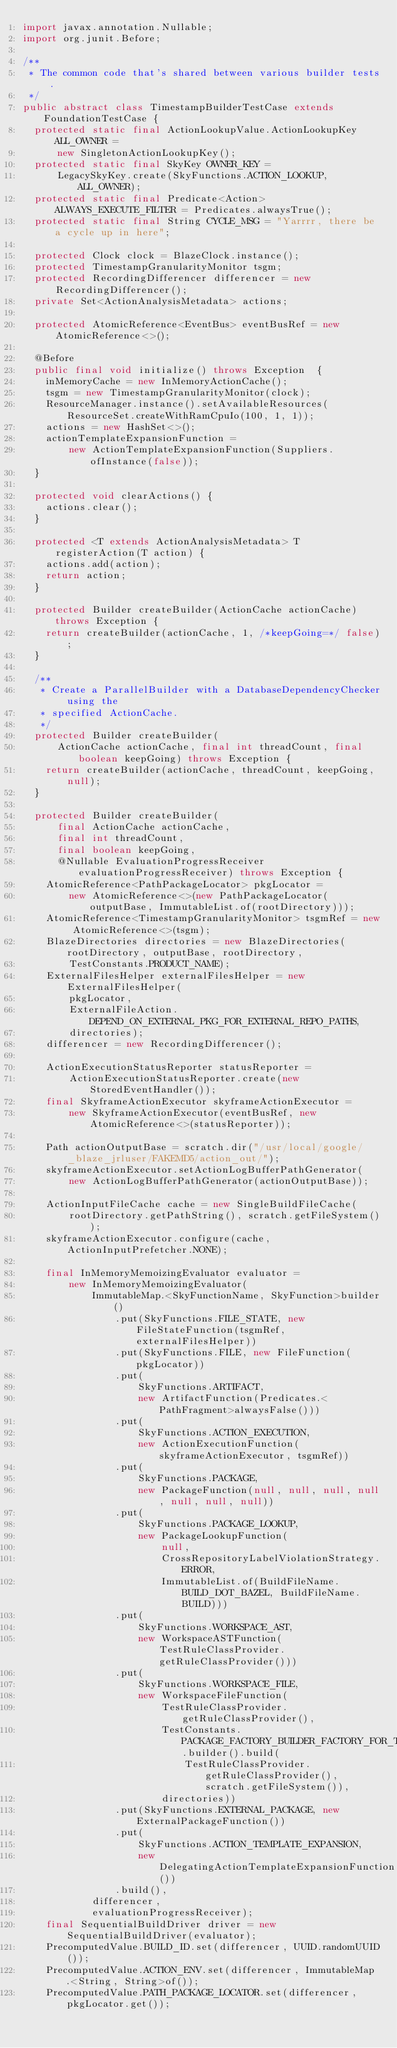<code> <loc_0><loc_0><loc_500><loc_500><_Java_>import javax.annotation.Nullable;
import org.junit.Before;

/**
 * The common code that's shared between various builder tests.
 */
public abstract class TimestampBuilderTestCase extends FoundationTestCase {
  protected static final ActionLookupValue.ActionLookupKey ALL_OWNER =
      new SingletonActionLookupKey();
  protected static final SkyKey OWNER_KEY =
      LegacySkyKey.create(SkyFunctions.ACTION_LOOKUP, ALL_OWNER);
  protected static final Predicate<Action> ALWAYS_EXECUTE_FILTER = Predicates.alwaysTrue();
  protected static final String CYCLE_MSG = "Yarrrr, there be a cycle up in here";

  protected Clock clock = BlazeClock.instance();
  protected TimestampGranularityMonitor tsgm;
  protected RecordingDifferencer differencer = new RecordingDifferencer();
  private Set<ActionAnalysisMetadata> actions;

  protected AtomicReference<EventBus> eventBusRef = new AtomicReference<>();

  @Before
  public final void initialize() throws Exception  {
    inMemoryCache = new InMemoryActionCache();
    tsgm = new TimestampGranularityMonitor(clock);
    ResourceManager.instance().setAvailableResources(ResourceSet.createWithRamCpuIo(100, 1, 1));
    actions = new HashSet<>();
    actionTemplateExpansionFunction =
        new ActionTemplateExpansionFunction(Suppliers.ofInstance(false));
  }

  protected void clearActions() {
    actions.clear();
  }

  protected <T extends ActionAnalysisMetadata> T registerAction(T action) {
    actions.add(action);
    return action;
  }

  protected Builder createBuilder(ActionCache actionCache) throws Exception {
    return createBuilder(actionCache, 1, /*keepGoing=*/ false);
  }

  /**
   * Create a ParallelBuilder with a DatabaseDependencyChecker using the
   * specified ActionCache.
   */
  protected Builder createBuilder(
      ActionCache actionCache, final int threadCount, final boolean keepGoing) throws Exception {
    return createBuilder(actionCache, threadCount, keepGoing, null);
  }

  protected Builder createBuilder(
      final ActionCache actionCache,
      final int threadCount,
      final boolean keepGoing,
      @Nullable EvaluationProgressReceiver evaluationProgressReceiver) throws Exception {
    AtomicReference<PathPackageLocator> pkgLocator =
        new AtomicReference<>(new PathPackageLocator(outputBase, ImmutableList.of(rootDirectory)));
    AtomicReference<TimestampGranularityMonitor> tsgmRef = new AtomicReference<>(tsgm);
    BlazeDirectories directories = new BlazeDirectories(rootDirectory, outputBase, rootDirectory,
        TestConstants.PRODUCT_NAME);
    ExternalFilesHelper externalFilesHelper = new ExternalFilesHelper(
        pkgLocator,
        ExternalFileAction.DEPEND_ON_EXTERNAL_PKG_FOR_EXTERNAL_REPO_PATHS,
        directories);
    differencer = new RecordingDifferencer();

    ActionExecutionStatusReporter statusReporter =
        ActionExecutionStatusReporter.create(new StoredEventHandler());
    final SkyframeActionExecutor skyframeActionExecutor =
        new SkyframeActionExecutor(eventBusRef, new AtomicReference<>(statusReporter));

    Path actionOutputBase = scratch.dir("/usr/local/google/_blaze_jrluser/FAKEMD5/action_out/");
    skyframeActionExecutor.setActionLogBufferPathGenerator(
        new ActionLogBufferPathGenerator(actionOutputBase));

    ActionInputFileCache cache = new SingleBuildFileCache(
        rootDirectory.getPathString(), scratch.getFileSystem());
    skyframeActionExecutor.configure(cache, ActionInputPrefetcher.NONE);

    final InMemoryMemoizingEvaluator evaluator =
        new InMemoryMemoizingEvaluator(
            ImmutableMap.<SkyFunctionName, SkyFunction>builder()
                .put(SkyFunctions.FILE_STATE, new FileStateFunction(tsgmRef, externalFilesHelper))
                .put(SkyFunctions.FILE, new FileFunction(pkgLocator))
                .put(
                    SkyFunctions.ARTIFACT,
                    new ArtifactFunction(Predicates.<PathFragment>alwaysFalse()))
                .put(
                    SkyFunctions.ACTION_EXECUTION,
                    new ActionExecutionFunction(skyframeActionExecutor, tsgmRef))
                .put(
                    SkyFunctions.PACKAGE,
                    new PackageFunction(null, null, null, null, null, null, null))
                .put(
                    SkyFunctions.PACKAGE_LOOKUP,
                    new PackageLookupFunction(
                        null,
                        CrossRepositoryLabelViolationStrategy.ERROR,
                        ImmutableList.of(BuildFileName.BUILD_DOT_BAZEL, BuildFileName.BUILD)))
                .put(
                    SkyFunctions.WORKSPACE_AST,
                    new WorkspaceASTFunction(TestRuleClassProvider.getRuleClassProvider()))
                .put(
                    SkyFunctions.WORKSPACE_FILE,
                    new WorkspaceFileFunction(
                        TestRuleClassProvider.getRuleClassProvider(),
                        TestConstants.PACKAGE_FACTORY_BUILDER_FACTORY_FOR_TESTING.builder().build(
                            TestRuleClassProvider.getRuleClassProvider(), scratch.getFileSystem()),
                        directories))
                .put(SkyFunctions.EXTERNAL_PACKAGE, new ExternalPackageFunction())
                .put(
                    SkyFunctions.ACTION_TEMPLATE_EXPANSION,
                    new DelegatingActionTemplateExpansionFunction())
                .build(),
            differencer,
            evaluationProgressReceiver);
    final SequentialBuildDriver driver = new SequentialBuildDriver(evaluator);
    PrecomputedValue.BUILD_ID.set(differencer, UUID.randomUUID());
    PrecomputedValue.ACTION_ENV.set(differencer, ImmutableMap.<String, String>of());
    PrecomputedValue.PATH_PACKAGE_LOCATOR.set(differencer, pkgLocator.get());
</code> 